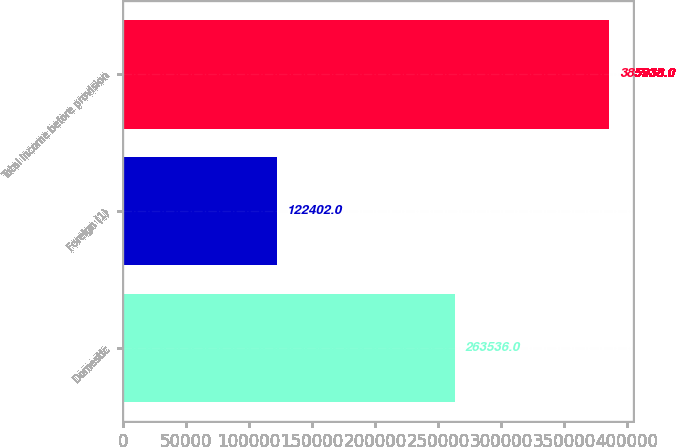Convert chart to OTSL. <chart><loc_0><loc_0><loc_500><loc_500><bar_chart><fcel>Domestic<fcel>Foreign (1)<fcel>Total income before provision<nl><fcel>263536<fcel>122402<fcel>385938<nl></chart> 